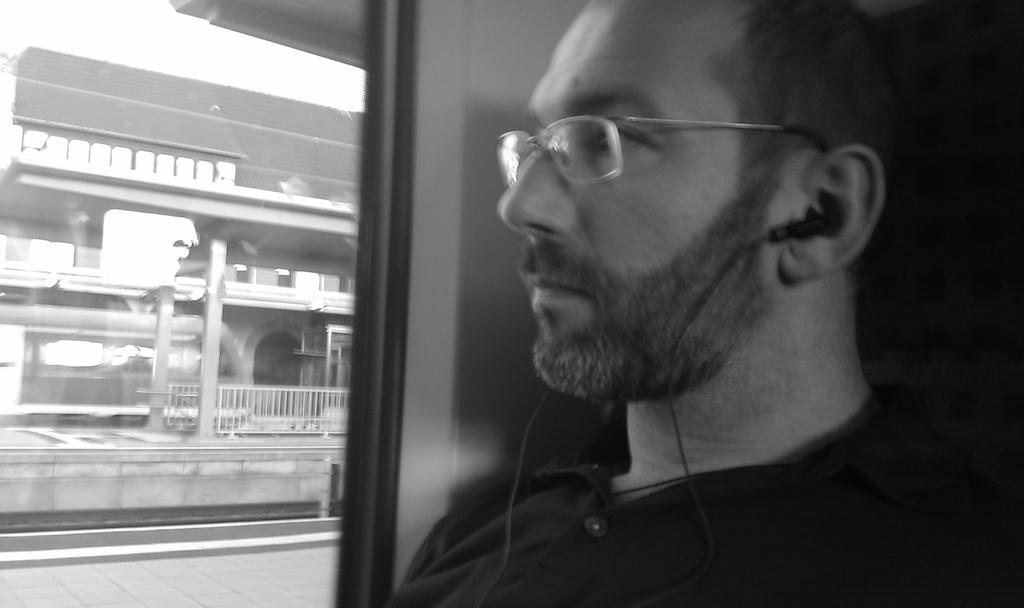Who is present in the image? There is a person in the image. What can be seen on the person's face? The person is wearing spectacles. What is the person wearing on their ears? The person is wearing earphones. What is visible through the glass in the image? Buildings and a fence are visible through the glass. What is the color scheme of the image? The image is black and white. What channel is the person watching on the quartz television in the image? There is no television, quartz or otherwise, present in the image. 